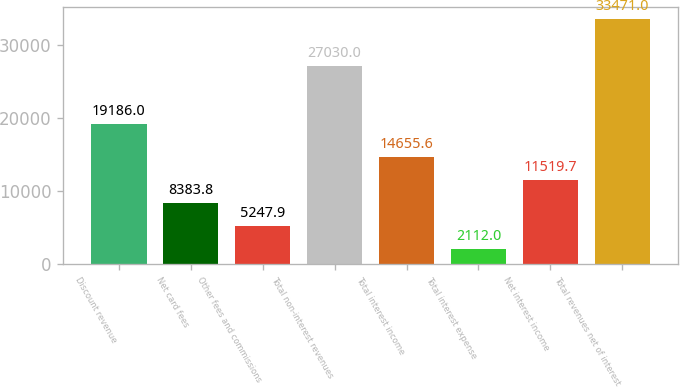<chart> <loc_0><loc_0><loc_500><loc_500><bar_chart><fcel>Discount revenue<fcel>Net card fees<fcel>Other fees and commissions<fcel>Total non-interest revenues<fcel>Total interest income<fcel>Total interest expense<fcel>Net interest income<fcel>Total revenues net of interest<nl><fcel>19186<fcel>8383.8<fcel>5247.9<fcel>27030<fcel>14655.6<fcel>2112<fcel>11519.7<fcel>33471<nl></chart> 